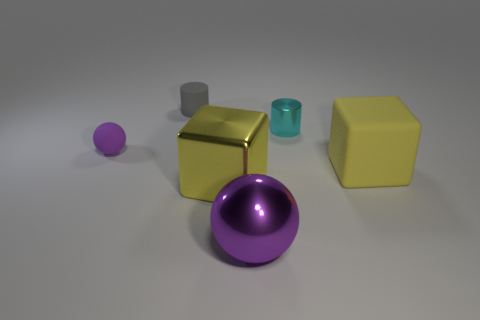Subtract all gray cylinders. How many cylinders are left? 1 Subtract 2 blocks. How many blocks are left? 0 Subtract all gray spheres. How many gray cylinders are left? 1 Add 3 gray rubber objects. How many objects exist? 9 Subtract all spheres. How many objects are left? 4 Subtract 0 gray blocks. How many objects are left? 6 Subtract all gray blocks. Subtract all brown cylinders. How many blocks are left? 2 Subtract all small green blocks. Subtract all large purple things. How many objects are left? 5 Add 6 cyan metal cylinders. How many cyan metal cylinders are left? 7 Add 2 big purple spheres. How many big purple spheres exist? 3 